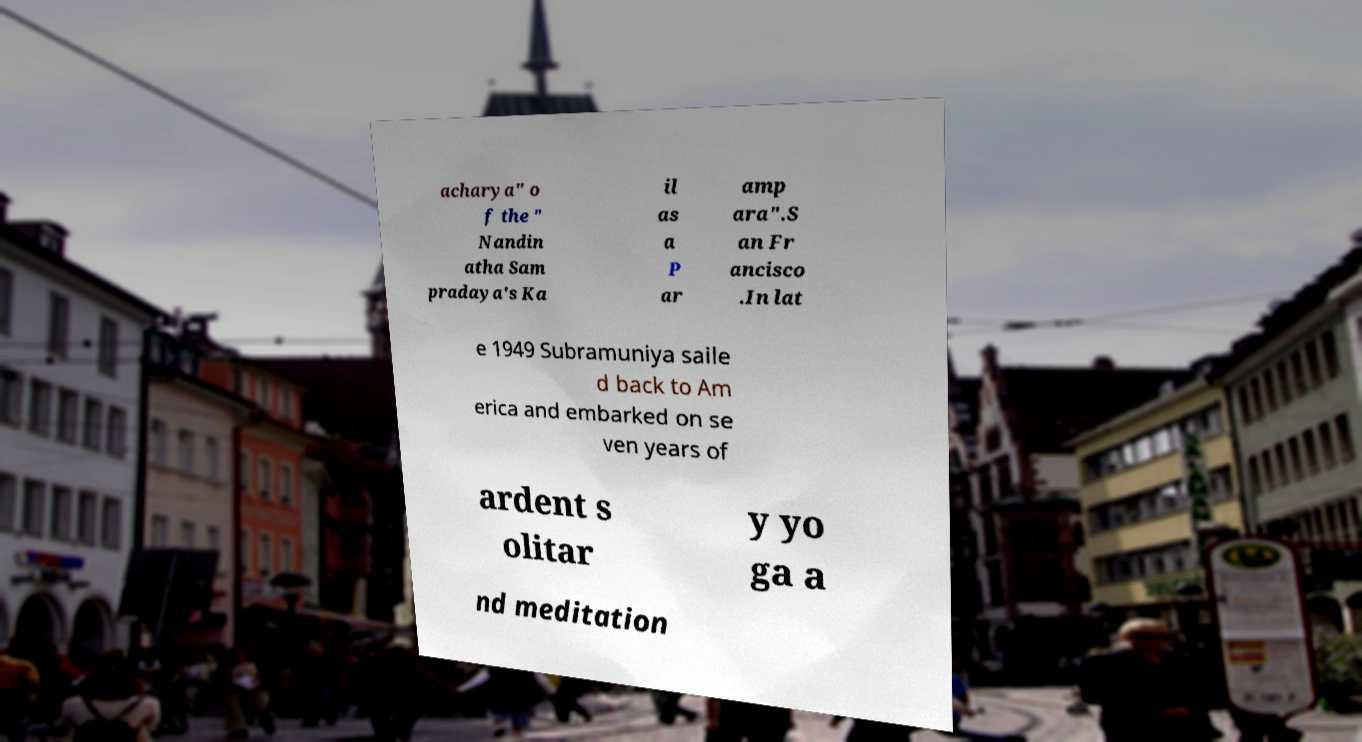There's text embedded in this image that I need extracted. Can you transcribe it verbatim? acharya" o f the " Nandin atha Sam pradaya's Ka il as a P ar amp ara".S an Fr ancisco .In lat e 1949 Subramuniya saile d back to Am erica and embarked on se ven years of ardent s olitar y yo ga a nd meditation 